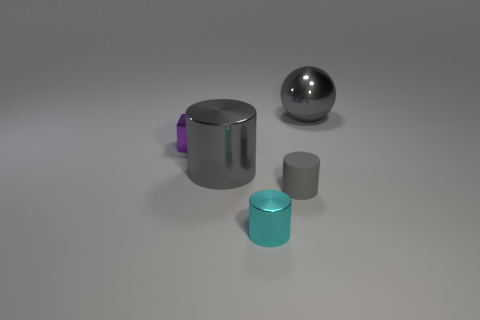Subtract all small cylinders. How many cylinders are left? 1 Subtract all cyan cylinders. How many cylinders are left? 2 Subtract all blocks. How many objects are left? 4 Subtract 2 cylinders. How many cylinders are left? 1 Add 4 small purple metal blocks. How many small purple metal blocks exist? 5 Add 4 gray shiny cylinders. How many objects exist? 9 Subtract 0 purple spheres. How many objects are left? 5 Subtract all green cylinders. Subtract all blue blocks. How many cylinders are left? 3 Subtract all cyan balls. How many cyan cubes are left? 0 Subtract all cyan shiny cylinders. Subtract all gray metallic balls. How many objects are left? 3 